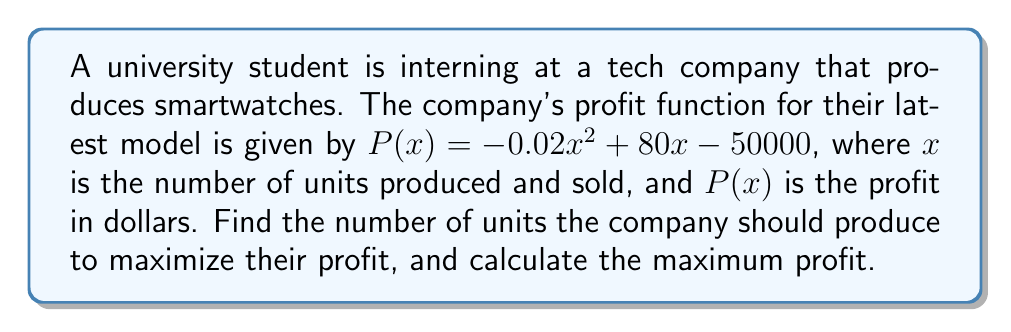Can you solve this math problem? To find the maximum profit, we need to optimize the given profit function. Here's how we can do it step-by-step:

1) The profit function is a quadratic function: $P(x) = -0.02x^2 + 80x - 50000$

2) To find the maximum, we need to find the critical point. We do this by taking the derivative of $P(x)$ and setting it equal to zero:

   $P'(x) = -0.04x + 80$

3) Set $P'(x) = 0$ and solve for $x$:
   
   $-0.04x + 80 = 0$
   $-0.04x = -80$
   $x = 2000$

4) The critical point is at $x = 2000$. Since the coefficient of $x^2$ in the original function is negative (-0.02), this critical point is a maximum.

5) To find the maximum profit, we plug $x = 2000$ into the original profit function:

   $P(2000) = -0.02(2000)^2 + 80(2000) - 50000$
             $= -80000 + 160000 - 50000$
             $= 30000$

Therefore, the company should produce 2000 units to maximize their profit, and the maximum profit will be $30,000.
Answer: 2000 units; $30,000 